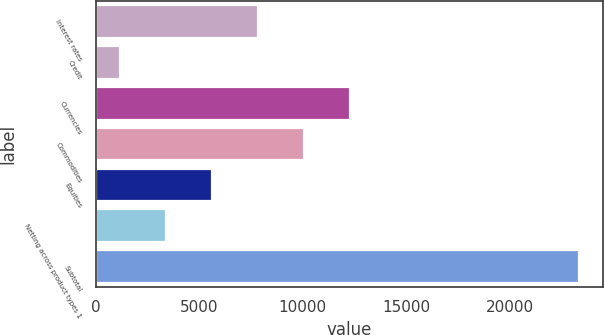Convert chart. <chart><loc_0><loc_0><loc_500><loc_500><bar_chart><fcel>Interest rates<fcel>Credit<fcel>Currencies<fcel>Commodities<fcel>Equities<fcel>Netting across product types 1<fcel>Subtotal<nl><fcel>7846.2<fcel>1200<fcel>12277<fcel>10061.6<fcel>5630.8<fcel>3415.4<fcel>23354<nl></chart> 